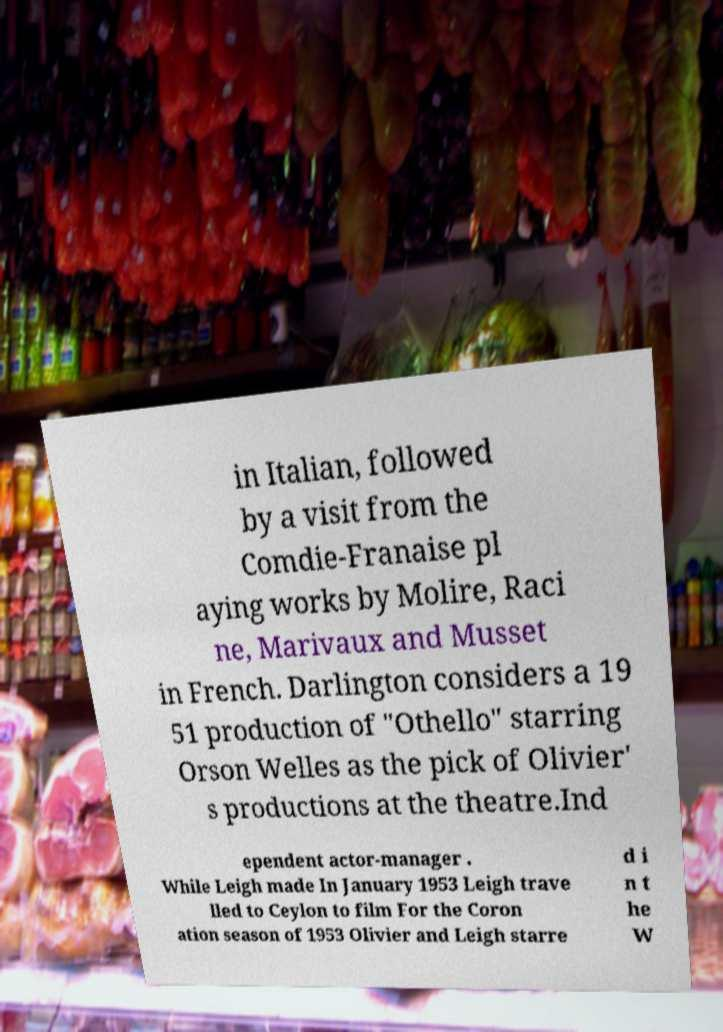For documentation purposes, I need the text within this image transcribed. Could you provide that? in Italian, followed by a visit from the Comdie-Franaise pl aying works by Molire, Raci ne, Marivaux and Musset in French. Darlington considers a 19 51 production of "Othello" starring Orson Welles as the pick of Olivier' s productions at the theatre.Ind ependent actor-manager . While Leigh made In January 1953 Leigh trave lled to Ceylon to film For the Coron ation season of 1953 Olivier and Leigh starre d i n t he W 